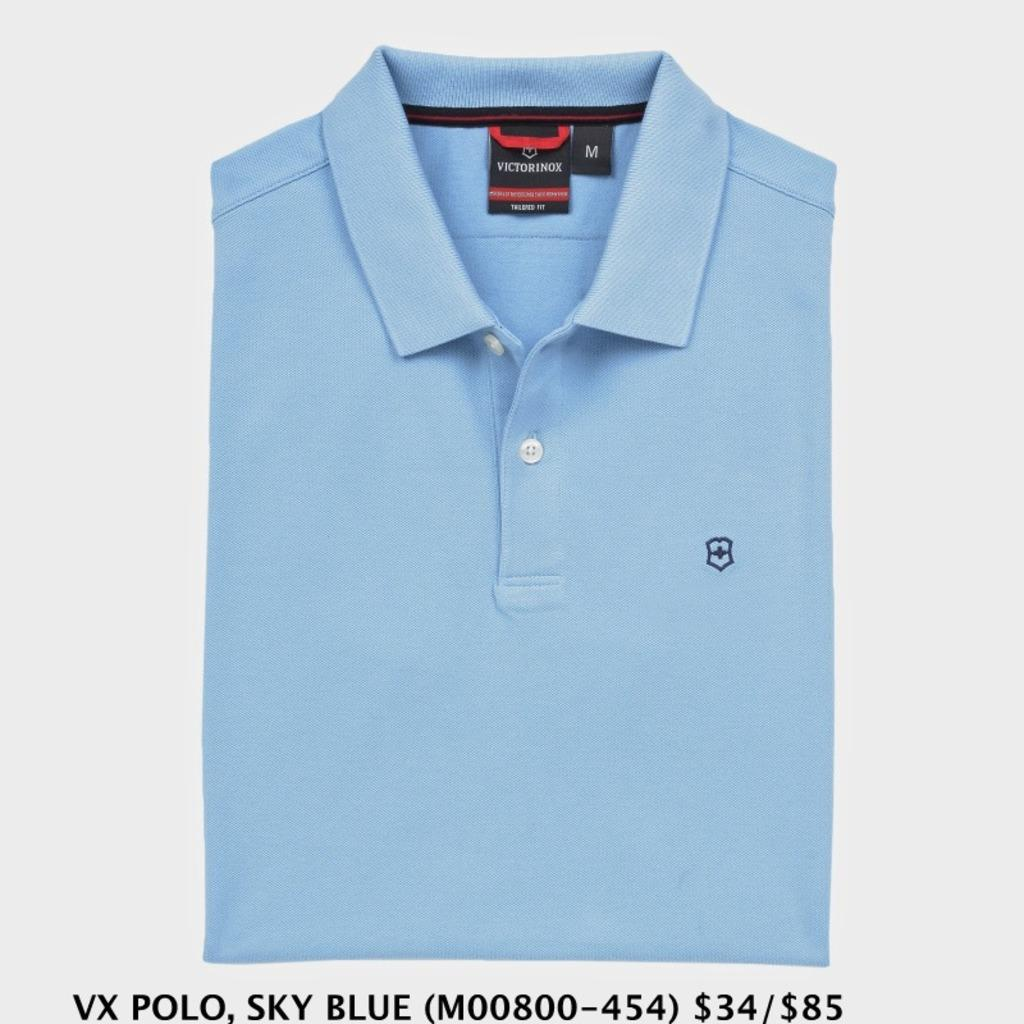What color is the t-shirt in the image? The t-shirt in the image is blue. What type of information is present on the t-shirt? The t-shirt has a size and brand tag. Where can additional information about the t-shirt be found in the image? Below the t-shirt, there is information about the brand, color, and rate of the t-shirt in the image. How many rabbits are sitting on the sign in the image? There is no sign or rabbits present in the image. What type of clothing are the women wearing in the image? There are no women present in the image; it only features a blue t-shirt. 